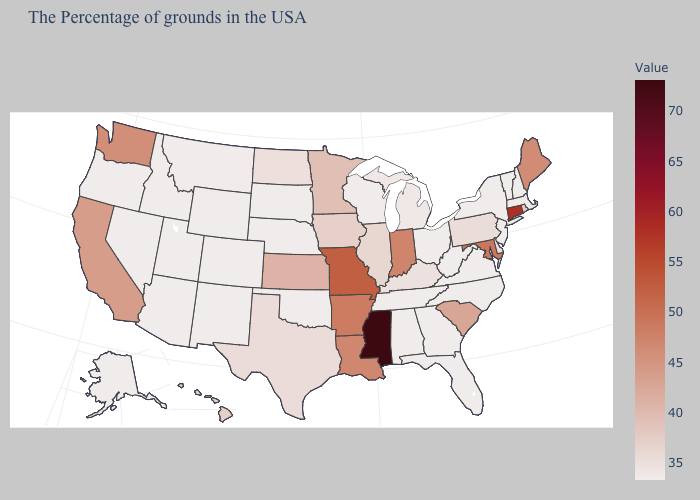Which states have the lowest value in the USA?
Be succinct. New Hampshire, Vermont, New York, New Jersey, Virginia, North Carolina, West Virginia, Ohio, Florida, Georgia, Alabama, Tennessee, Wisconsin, Nebraska, Oklahoma, South Dakota, Wyoming, Colorado, New Mexico, Utah, Arizona, Idaho, Nevada, Oregon, Alaska. Is the legend a continuous bar?
Give a very brief answer. Yes. Which states have the lowest value in the USA?
Give a very brief answer. New Hampshire, Vermont, New York, New Jersey, Virginia, North Carolina, West Virginia, Ohio, Florida, Georgia, Alabama, Tennessee, Wisconsin, Nebraska, Oklahoma, South Dakota, Wyoming, Colorado, New Mexico, Utah, Arizona, Idaho, Nevada, Oregon, Alaska. Does Missouri have the highest value in the MidWest?
Give a very brief answer. Yes. Does Minnesota have the highest value in the USA?
Concise answer only. No. Does Pennsylvania have the lowest value in the Northeast?
Concise answer only. No. Does West Virginia have a lower value than Minnesota?
Keep it brief. Yes. Which states have the lowest value in the South?
Quick response, please. Virginia, North Carolina, West Virginia, Florida, Georgia, Alabama, Tennessee, Oklahoma. 